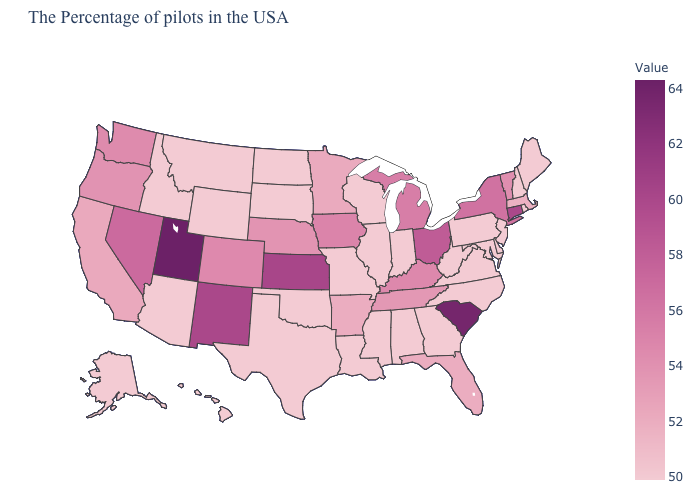Which states hav the highest value in the South?
Concise answer only. South Carolina. Among the states that border West Virginia , which have the lowest value?
Keep it brief. Maryland, Pennsylvania, Virginia. Does Hawaii have a higher value than Washington?
Keep it brief. No. Is the legend a continuous bar?
Quick response, please. Yes. Does Alaska have the lowest value in the USA?
Quick response, please. Yes. Among the states that border Iowa , which have the lowest value?
Be succinct. Wisconsin, Illinois, Missouri, South Dakota. Does South Dakota have a higher value than Ohio?
Answer briefly. No. Does the map have missing data?
Keep it brief. No. 